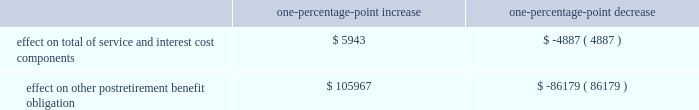The discount rate assumption was determined for the pension and postretirement benefit plans independently .
At year-end 2011 , the company began using an approach that approximates the process of settlement of obligations tailored to the plans 2019 expected cash flows by matching the plans 2019 cash flows to the coupons and expected maturity values of individually selected bonds .
The yield curve was developed for a universe containing the majority of u.s.-issued aa-graded corporate bonds , all of which were non callable ( or callable with make-whole provisions ) .
Historically , for each plan , the discount rate was developed as the level equivalent rate that would produce the same present value as that using spot rates aligned with the projected benefit payments .
The expected long-term rate of return on plan assets is based on historical and projected rates of return , prior to administrative and investment management fees , for current and planned asset classes in the plans 2019 investment portfolios .
Assumed projected rates of return for each of the plans 2019 projected asset classes were selected after analyzing historical experience and future expectations of the returns and volatility of the various asset classes .
Based on the target asset allocation for each asset class , the overall expected rate of return for the portfolio was developed , adjusted for historical and expected experience of active portfolio management results compared to the benchmark returns and for the effect of expenses paid from plan assets .
The company 2019s pension expense increases as the expected return on assets decreases .
In the determination of year end 2014 projected benefit plan obligations , the company adopted a new table based on the society of actuaries rp 2014 mortality table including a generational bb-2d projection scale .
The adoption resulted in a significant increase to pension and other postretirement benefit plans 2019 projected benefit obligations .
Assumed health care cost trend rates have a significant effect on the amounts reported for the other postretirement benefit plans .
The health care cost trend rate is based on historical rates and expected market conditions .
A one-percentage-point change in assumed health care cost trend rates would have the following effects : one-percentage-point increase one-percentage-point decrease effect on total of service and interest cost components .
$ 5943 $ ( 4887 ) effect on other postretirement benefit obligation .
$ 105967 $ ( 86179 ) .
The discount rate assumption was determined for the pension and postretirement benefit plans independently .
At year-end 2011 , the company began using an approach that approximates the process of settlement of obligations tailored to the plans 2019 expected cash flows by matching the plans 2019 cash flows to the coupons and expected maturity values of individually selected bonds .
The yield curve was developed for a universe containing the majority of u.s.-issued aa-graded corporate bonds , all of which were non callable ( or callable with make-whole provisions ) .
Historically , for each plan , the discount rate was developed as the level equivalent rate that would produce the same present value as that using spot rates aligned with the projected benefit payments .
The expected long-term rate of return on plan assets is based on historical and projected rates of return , prior to administrative and investment management fees , for current and planned asset classes in the plans 2019 investment portfolios .
Assumed projected rates of return for each of the plans 2019 projected asset classes were selected after analyzing historical experience and future expectations of the returns and volatility of the various asset classes .
Based on the target asset allocation for each asset class , the overall expected rate of return for the portfolio was developed , adjusted for historical and expected experience of active portfolio management results compared to the benchmark returns and for the effect of expenses paid from plan assets .
The company 2019s pension expense increases as the expected return on assets decreases .
In the determination of year end 2014 projected benefit plan obligations , the company adopted a new table based on the society of actuaries rp 2014 mortality table including a generational bb-2d projection scale .
The adoption resulted in a significant increase to pension and other postretirement benefit plans 2019 projected benefit obligations .
Assumed health care cost trend rates have a significant effect on the amounts reported for the other postretirement benefit plans .
The health care cost trend rate is based on historical rates and expected market conditions .
A one-percentage-point change in assumed health care cost trend rates would have the following effects : one-percentage-point increase one-percentage-point decrease effect on total of service and interest cost components .
$ 5943 $ ( 4887 ) effect on other postretirement benefit obligation .
$ 105967 $ ( 86179 ) .
What would the effect on total of service and interest cost components as a result of a 2 percent point increase? 
Computations: (5943 * 2)
Answer: 11886.0. 